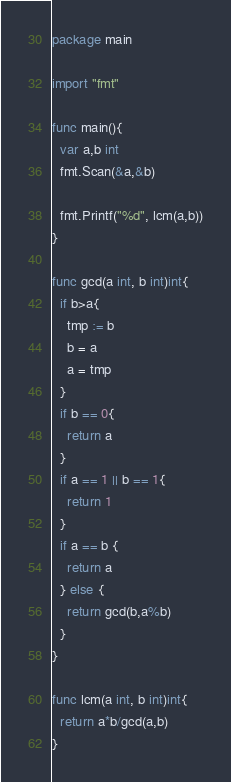<code> <loc_0><loc_0><loc_500><loc_500><_Go_>package main

import "fmt"

func main(){
  var a,b int
  fmt.Scan(&a,&b)

  fmt.Printf("%d", lcm(a,b))
}

func gcd(a int, b int)int{
  if b>a{
    tmp := b
    b = a
    a = tmp
  }
  if b == 0{
    return a
  }
  if a == 1 || b == 1{
    return 1
  }
  if a == b {
    return a
  } else {
    return gcd(b,a%b)
  }
}

func lcm(a int, b int)int{
  return a*b/gcd(a,b)
}
</code> 